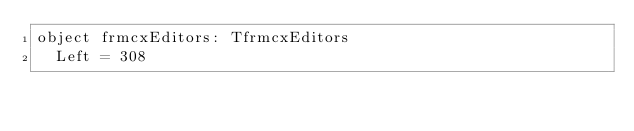<code> <loc_0><loc_0><loc_500><loc_500><_Pascal_>object frmcxEditors: TfrmcxEditors
  Left = 308</code> 